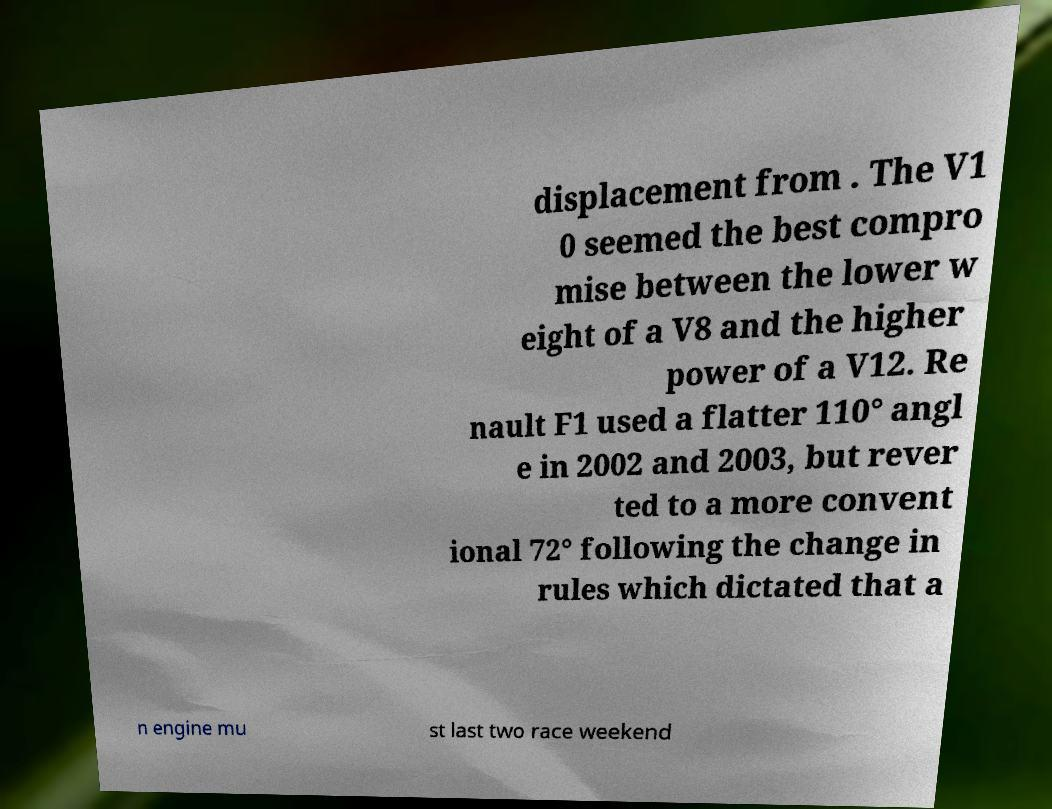What messages or text are displayed in this image? I need them in a readable, typed format. displacement from . The V1 0 seemed the best compro mise between the lower w eight of a V8 and the higher power of a V12. Re nault F1 used a flatter 110° angl e in 2002 and 2003, but rever ted to a more convent ional 72° following the change in rules which dictated that a n engine mu st last two race weekend 